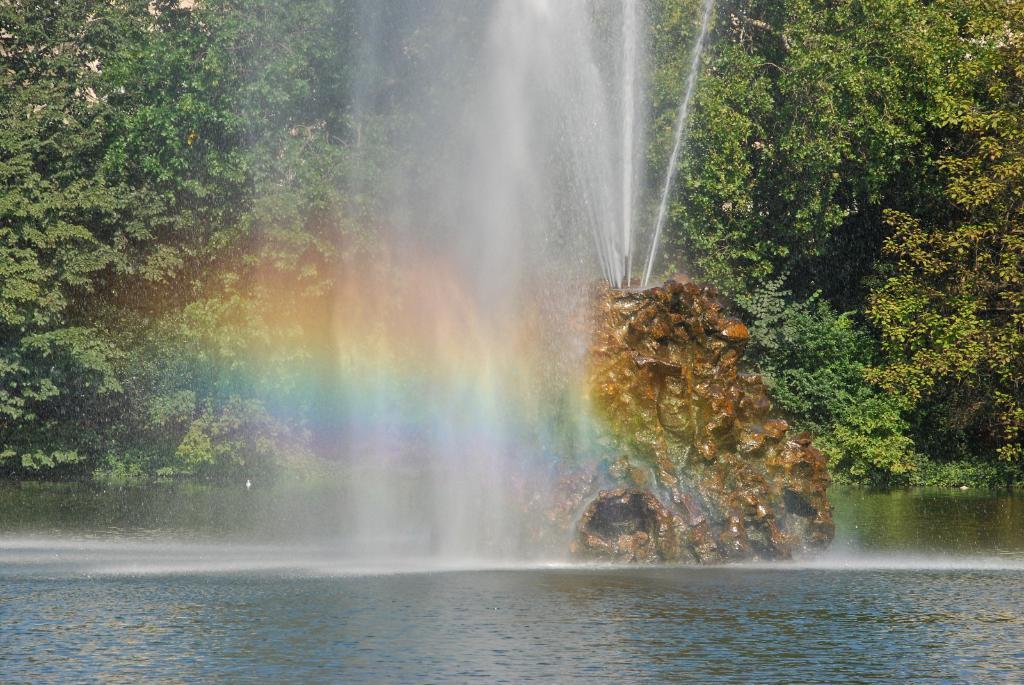What type of vegetation can be seen in the image? There are trees in the image. What is located on a stone in the image? There is a fountain on a stone in the image. What natural phenomenon is visible in the image? A rainbow is visible in the image. What is the primary source of water in the image? There is water visible in the image. How many lamps are hanging from the trees in the image? There are no lamps present in the image; it features trees, a fountain, a rainbow, and water. What type of vegetable is growing near the fountain in the image? There is no vegetable, specifically cabbage, present in the image. 